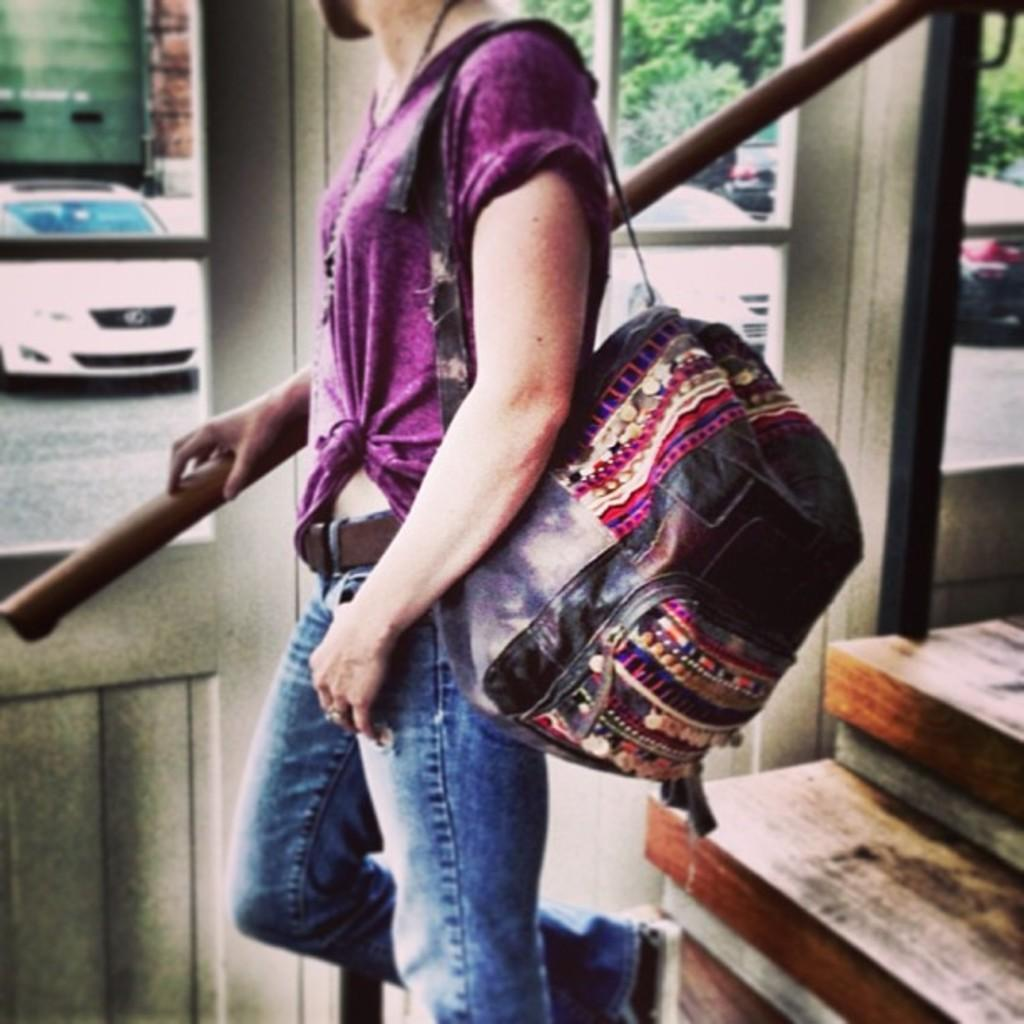What is present in the image? There is a person in the image. What is the person wearing in the image? The person is wearing a bag. What type of windows can be seen in the image? There are glass windows visible in the image. What can be seen through the windows in the image? Trees and vehicles are visible through the windows. What type of minister is present in the image? There is no minister present in the image. What form does the existence of the trees take in the image? The trees are visible through the windows in their natural form. 